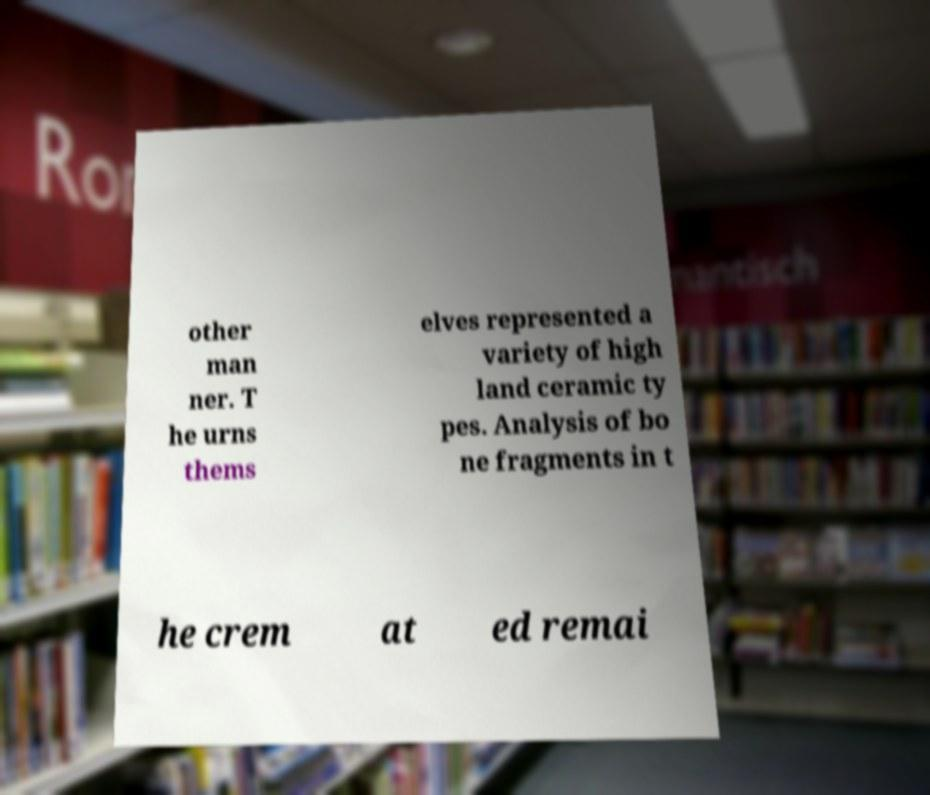There's text embedded in this image that I need extracted. Can you transcribe it verbatim? other man ner. T he urns thems elves represented a variety of high land ceramic ty pes. Analysis of bo ne fragments in t he crem at ed remai 